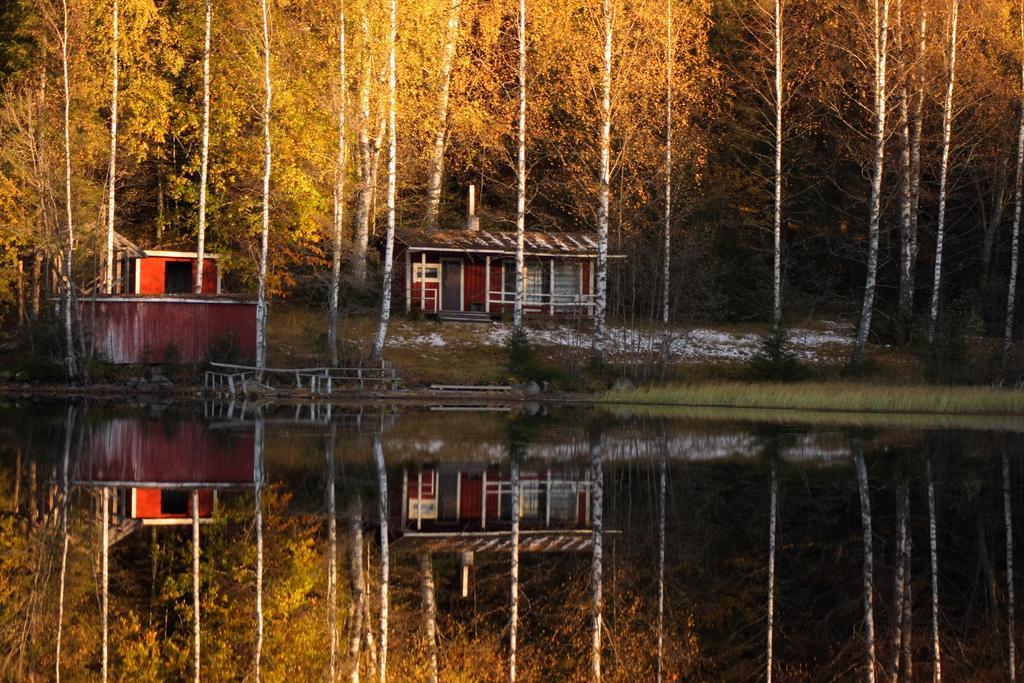In one or two sentences, can you explain what this image depicts? In this picture we can see water, few trees and houses. 